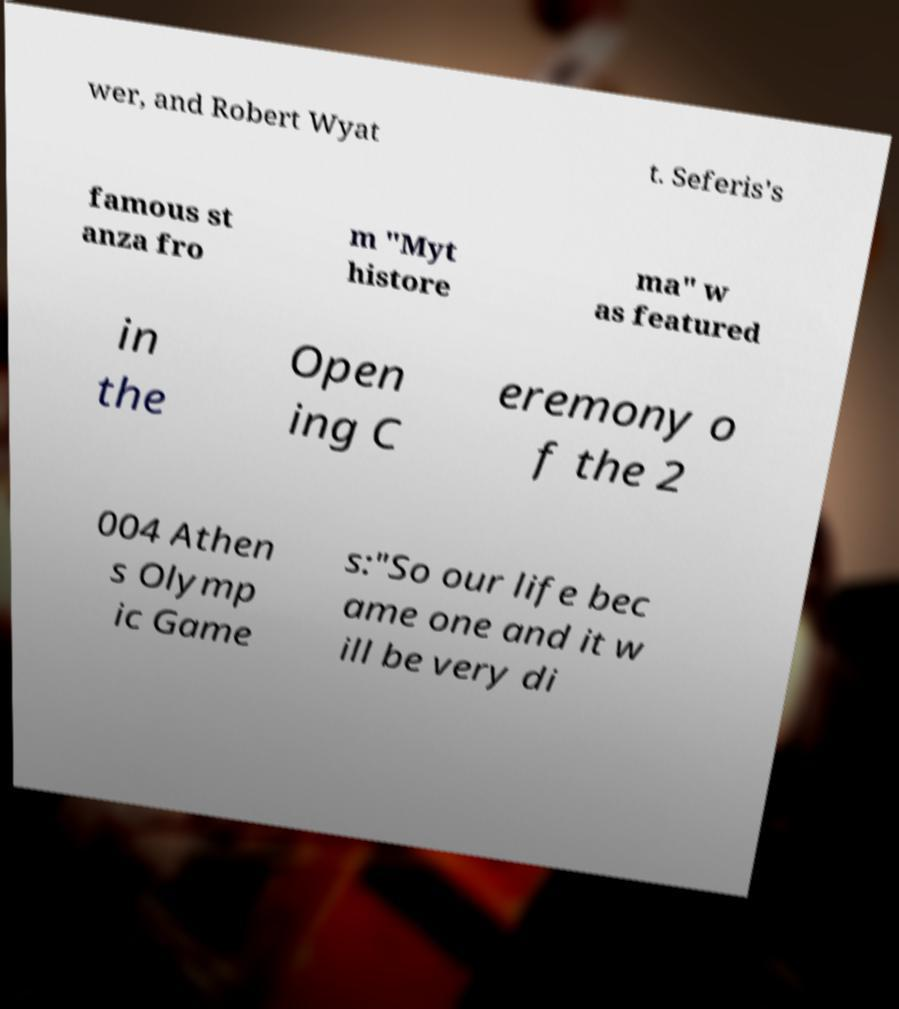What messages or text are displayed in this image? I need them in a readable, typed format. wer, and Robert Wyat t. Seferis's famous st anza fro m "Myt histore ma" w as featured in the Open ing C eremony o f the 2 004 Athen s Olymp ic Game s:"So our life bec ame one and it w ill be very di 